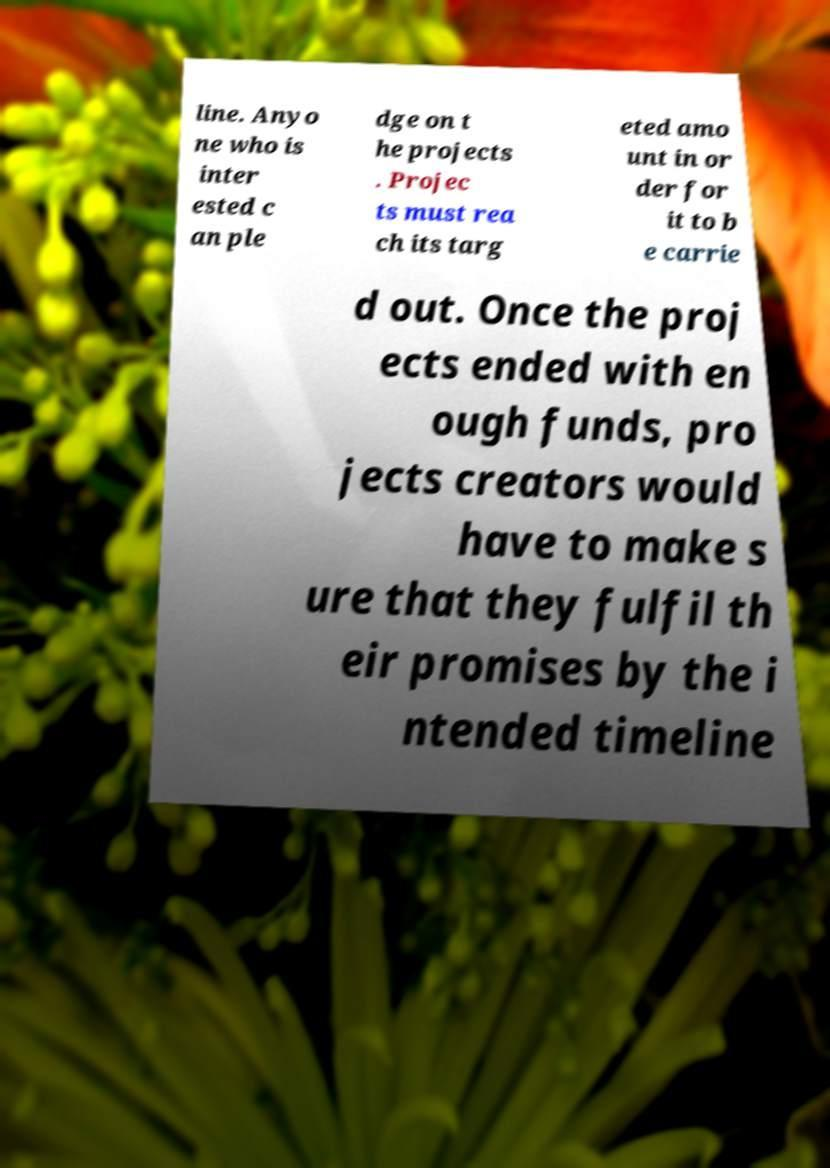Please identify and transcribe the text found in this image. line. Anyo ne who is inter ested c an ple dge on t he projects . Projec ts must rea ch its targ eted amo unt in or der for it to b e carrie d out. Once the proj ects ended with en ough funds, pro jects creators would have to make s ure that they fulfil th eir promises by the i ntended timeline 